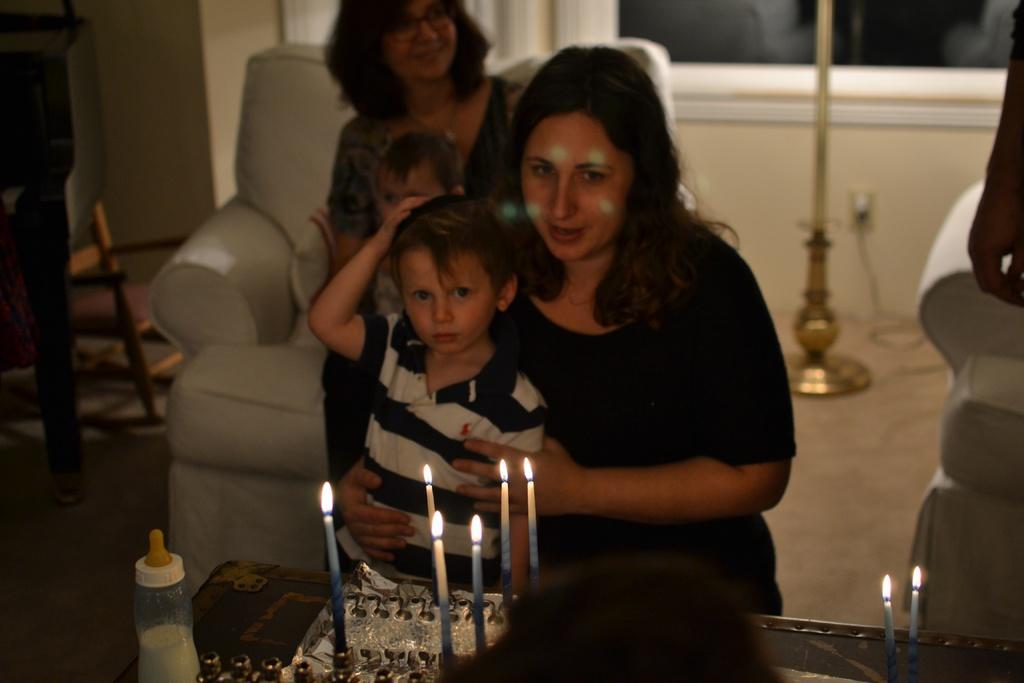Could you give a brief overview of what you see in this image? In this picture there are people and we can see cake, candles and bottle on the table and chairs. In the background of the image we can see wall, stand, cable and floor. 